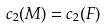<formula> <loc_0><loc_0><loc_500><loc_500>c _ { 2 } ( M ) = c _ { 2 } ( F )</formula> 